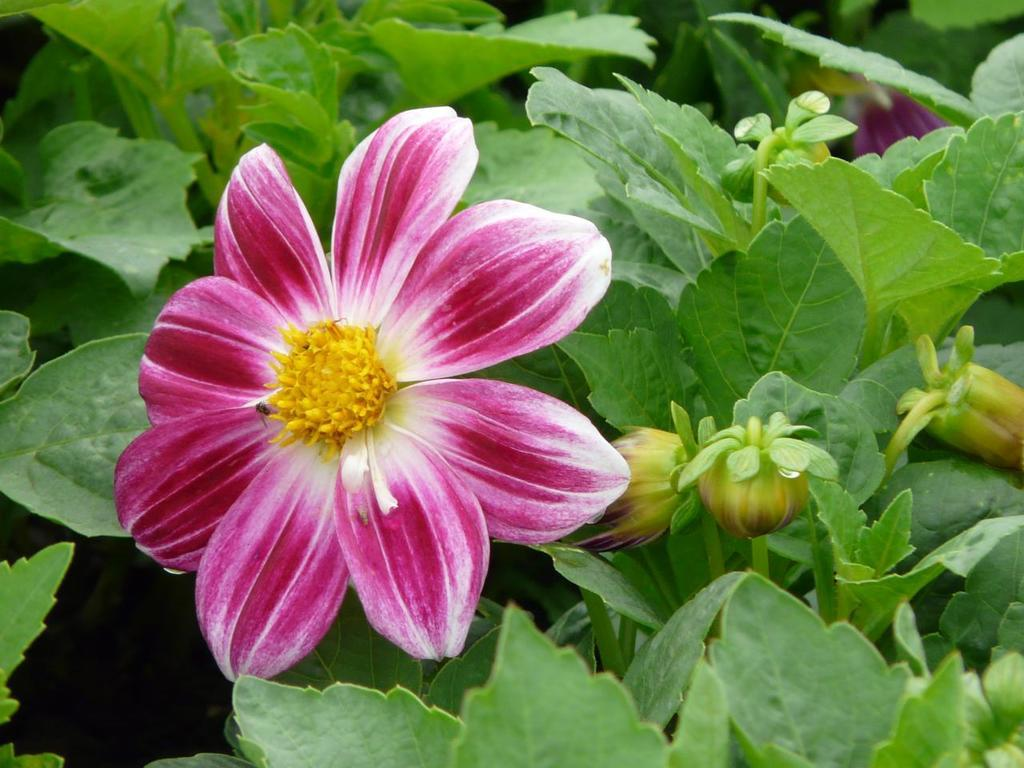What type of plant is featured in the image? There is a flower in the image. Where is the plant located in the image? There is a plant on the right side of the image. What else can be seen in the image besides the flower and plant? Leaves are visible in the image. What type of brake system is visible in the image? There is no brake system present in the image; it features a flower and a plant. 